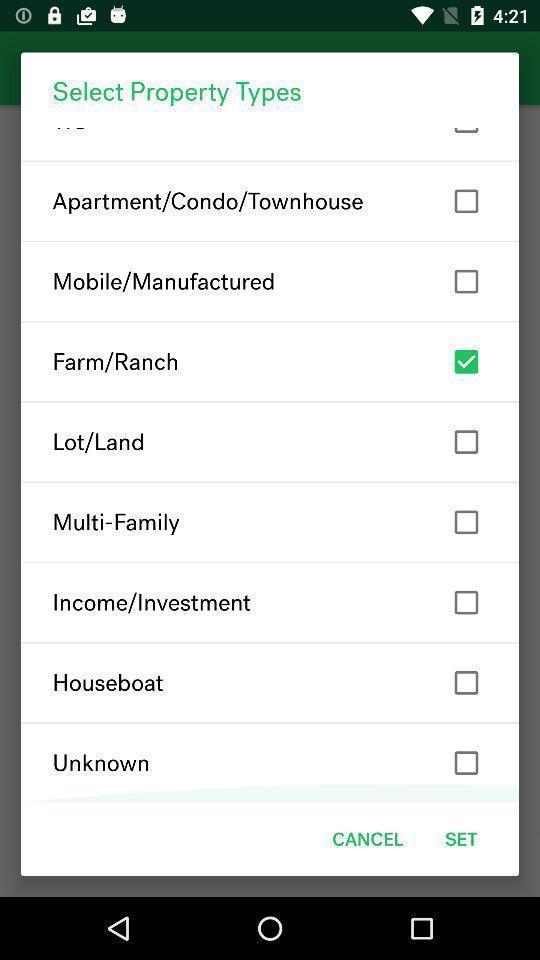Give me a summary of this screen capture. Popup page for selecting property types of home searching app. 